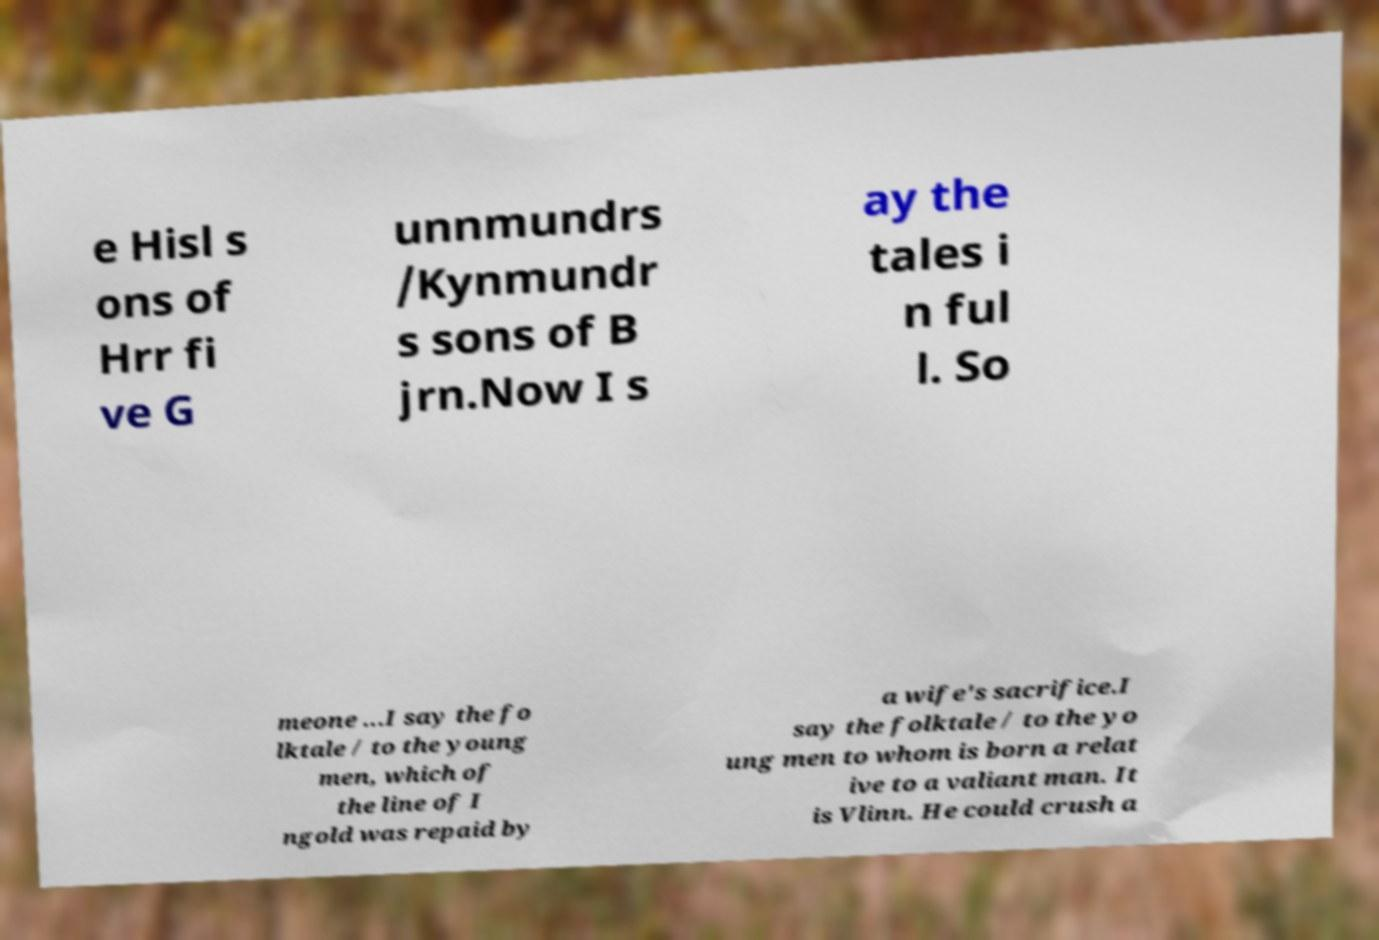For documentation purposes, I need the text within this image transcribed. Could you provide that? e Hisl s ons of Hrr fi ve G unnmundrs /Kynmundr s sons of B jrn.Now I s ay the tales i n ful l. So meone ...I say the fo lktale / to the young men, which of the line of I ngold was repaid by a wife's sacrifice.I say the folktale / to the yo ung men to whom is born a relat ive to a valiant man. It is Vlinn. He could crush a 